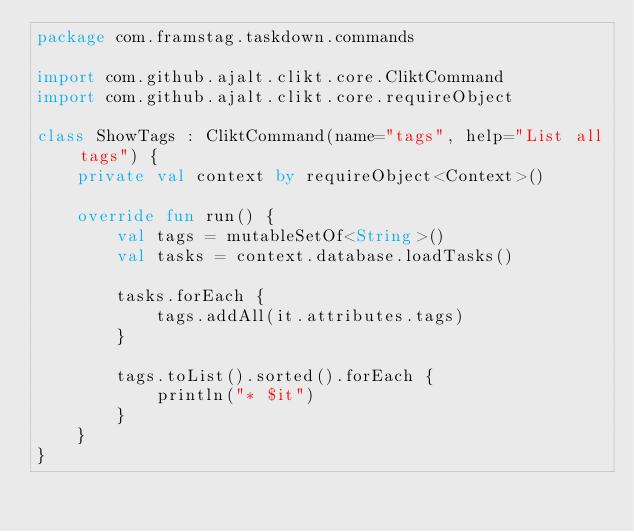Convert code to text. <code><loc_0><loc_0><loc_500><loc_500><_Kotlin_>package com.framstag.taskdown.commands

import com.github.ajalt.clikt.core.CliktCommand
import com.github.ajalt.clikt.core.requireObject

class ShowTags : CliktCommand(name="tags", help="List all tags") {
    private val context by requireObject<Context>()

    override fun run() {
        val tags = mutableSetOf<String>()
        val tasks = context.database.loadTasks()

        tasks.forEach {
            tags.addAll(it.attributes.tags)
        }

        tags.toList().sorted().forEach {
            println("* $it")
        }
    }
}
</code> 